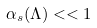<formula> <loc_0><loc_0><loc_500><loc_500>\alpha _ { s } ( \Lambda ) < < 1</formula> 